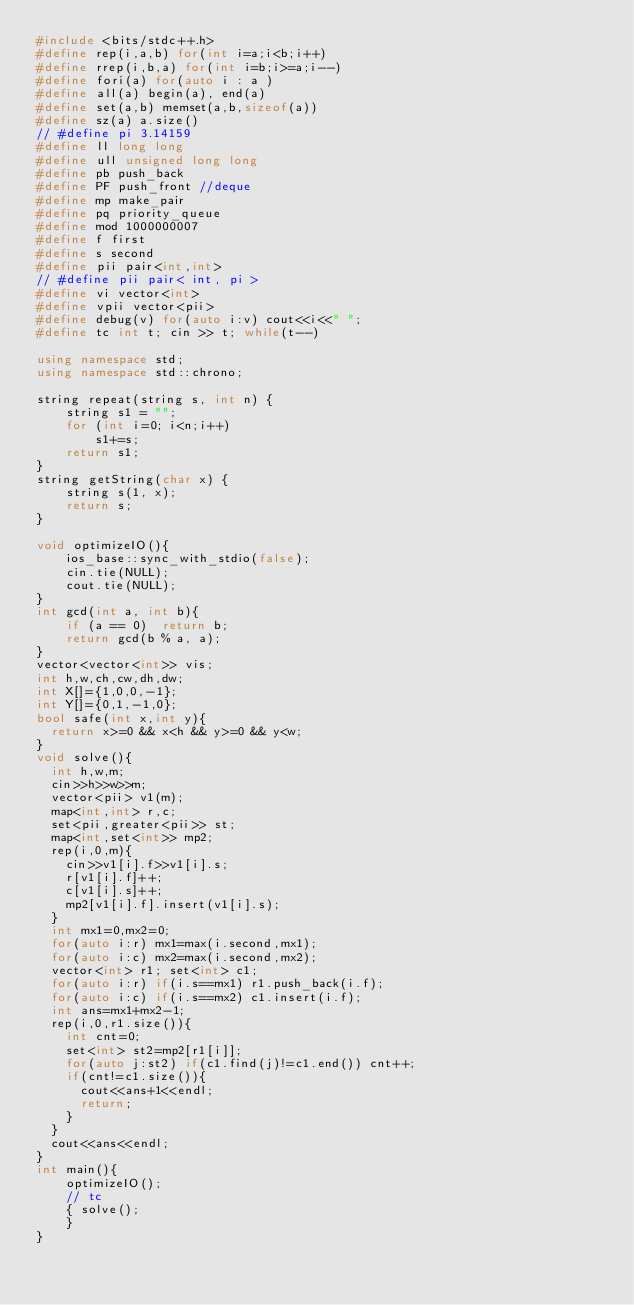<code> <loc_0><loc_0><loc_500><loc_500><_C++_>#include <bits/stdc++.h>
#define rep(i,a,b) for(int i=a;i<b;i++)
#define rrep(i,b,a) for(int i=b;i>=a;i--)
#define fori(a) for(auto i : a )
#define all(a) begin(a), end(a)
#define set(a,b) memset(a,b,sizeof(a))
#define sz(a) a.size()
// #define pi 3.14159
#define ll long long
#define ull unsigned long long
#define pb push_back
#define PF push_front //deque
#define mp make_pair
#define pq priority_queue
#define mod 1000000007
#define f first
#define s second
#define pii pair<int,int>
// #define pii pair< int, pi >
#define vi vector<int>
#define vpii vector<pii>
#define debug(v) for(auto i:v) cout<<i<<" ";
#define tc int t; cin >> t; while(t--)

using namespace std;
using namespace std::chrono;

string repeat(string s, int n) {
    string s1 = "";
    for (int i=0; i<n;i++)
        s1+=s;
    return s1;
}
string getString(char x) {
    string s(1, x);
    return s;
}

void optimizeIO(){
    ios_base::sync_with_stdio(false);
    cin.tie(NULL);
    cout.tie(NULL);
}
int gcd(int a, int b){
    if (a == 0)  return b;
    return gcd(b % a, a);
}
vector<vector<int>> vis;
int h,w,ch,cw,dh,dw;
int X[]={1,0,0,-1};
int Y[]={0,1,-1,0};
bool safe(int x,int y){
  return x>=0 && x<h && y>=0 && y<w;
}
void solve(){
	int h,w,m;
	cin>>h>>w>>m;
	vector<pii> v1(m);
	map<int,int> r,c;
	set<pii,greater<pii>> st;
	map<int,set<int>> mp2;
	rep(i,0,m){
		cin>>v1[i].f>>v1[i].s;
		r[v1[i].f]++;
		c[v1[i].s]++;
		mp2[v1[i].f].insert(v1[i].s);
	}
	int mx1=0,mx2=0;
	for(auto i:r) mx1=max(i.second,mx1);
	for(auto i:c) mx2=max(i.second,mx2);
	vector<int> r1; set<int> c1;
	for(auto i:r) if(i.s==mx1) r1.push_back(i.f);
	for(auto i:c) if(i.s==mx2) c1.insert(i.f);
	int ans=mx1+mx2-1;
	rep(i,0,r1.size()){
		int cnt=0;
		set<int> st2=mp2[r1[i]];
		for(auto j:st2) if(c1.find(j)!=c1.end()) cnt++;
		if(cnt!=c1.size()){
			cout<<ans+1<<endl;
			return;
		}
	}
	cout<<ans<<endl;
}
int main(){
    optimizeIO();
    // tc
    { solve();
    }
}
</code> 